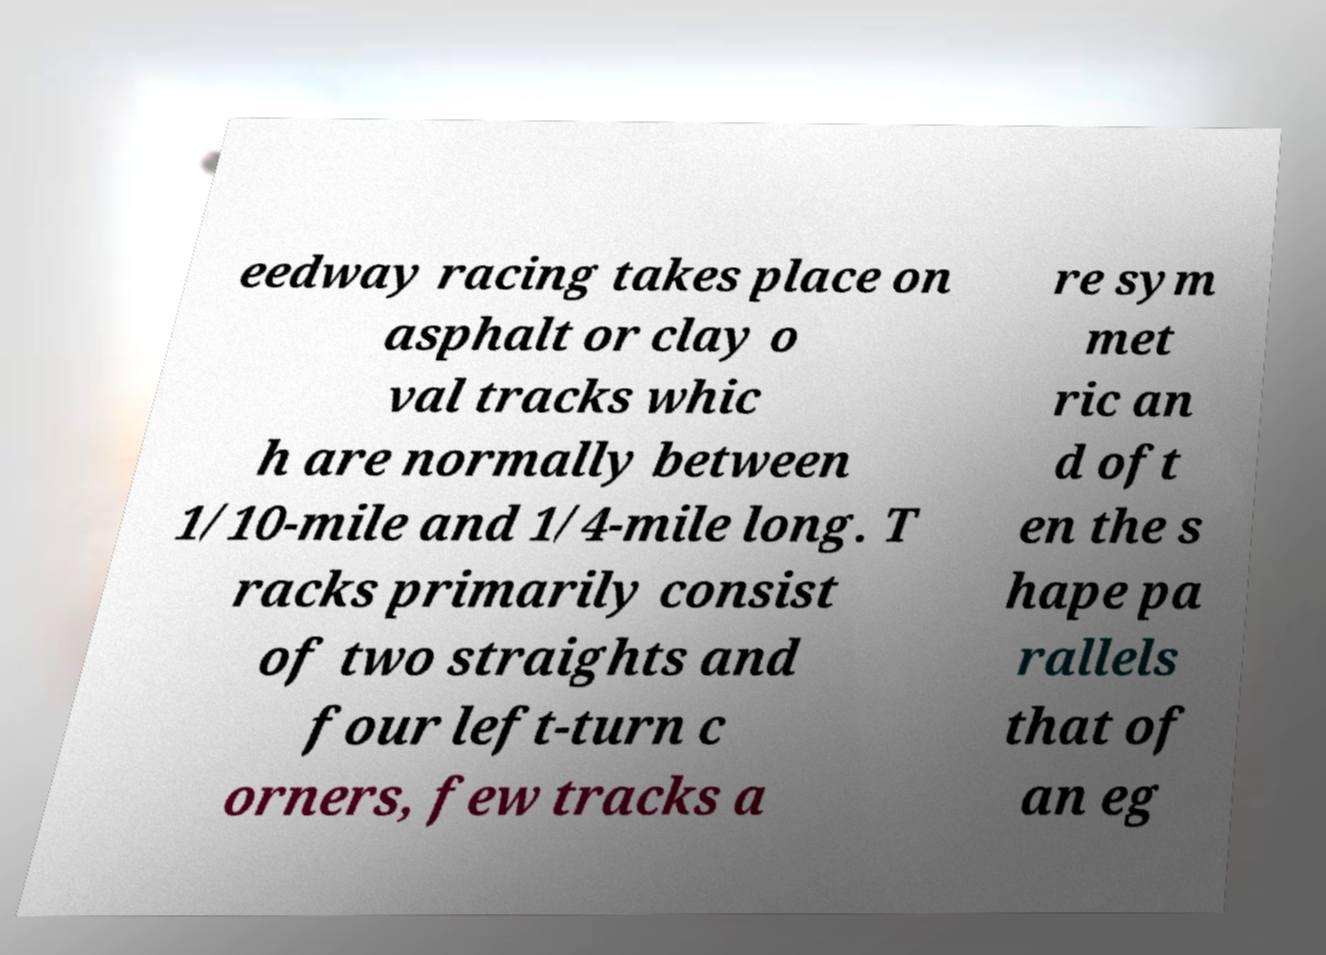Could you assist in decoding the text presented in this image and type it out clearly? eedway racing takes place on asphalt or clay o val tracks whic h are normally between 1/10-mile and 1/4-mile long. T racks primarily consist of two straights and four left-turn c orners, few tracks a re sym met ric an d oft en the s hape pa rallels that of an eg 